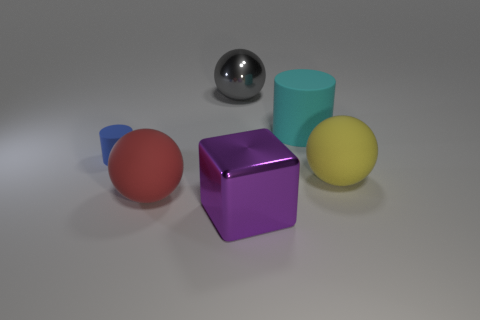Subtract all red balls. How many balls are left? 2 Subtract all red balls. How many balls are left? 2 Subtract all cylinders. How many objects are left? 4 Subtract all cyan blocks. Subtract all purple cylinders. How many blocks are left? 1 Add 1 blue metallic spheres. How many blue metallic spheres exist? 1 Add 3 spheres. How many objects exist? 9 Subtract 0 blue blocks. How many objects are left? 6 Subtract 2 spheres. How many spheres are left? 1 Subtract all cyan blocks. How many gray spheres are left? 1 Subtract all red cylinders. Subtract all yellow matte spheres. How many objects are left? 5 